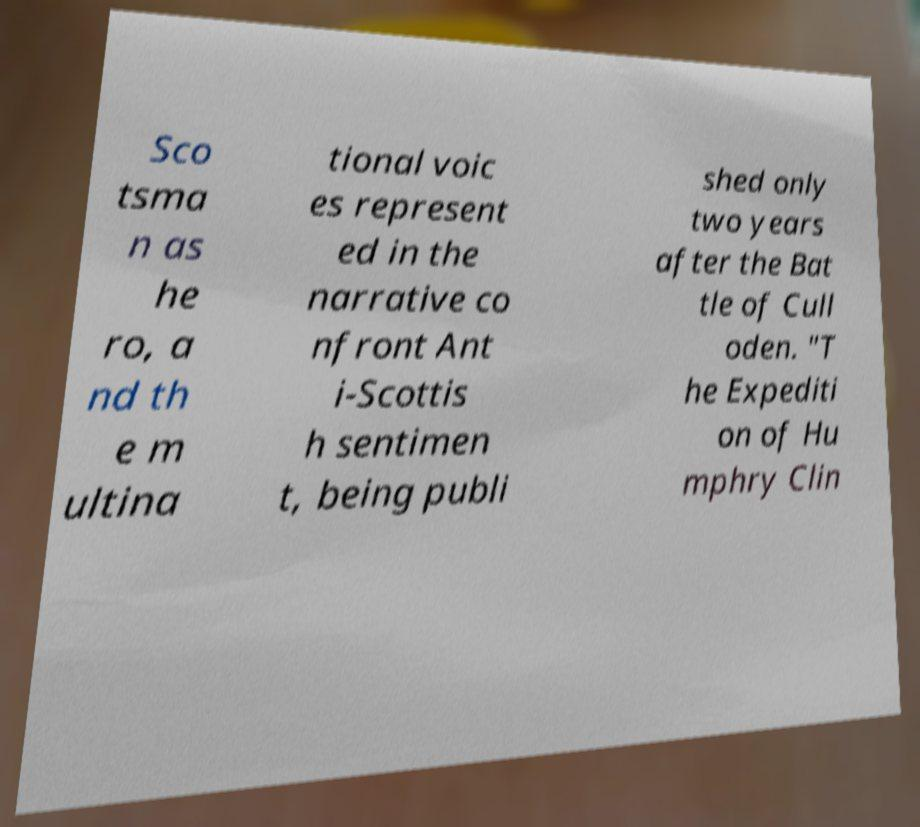What messages or text are displayed in this image? I need them in a readable, typed format. Sco tsma n as he ro, a nd th e m ultina tional voic es represent ed in the narrative co nfront Ant i-Scottis h sentimen t, being publi shed only two years after the Bat tle of Cull oden. "T he Expediti on of Hu mphry Clin 